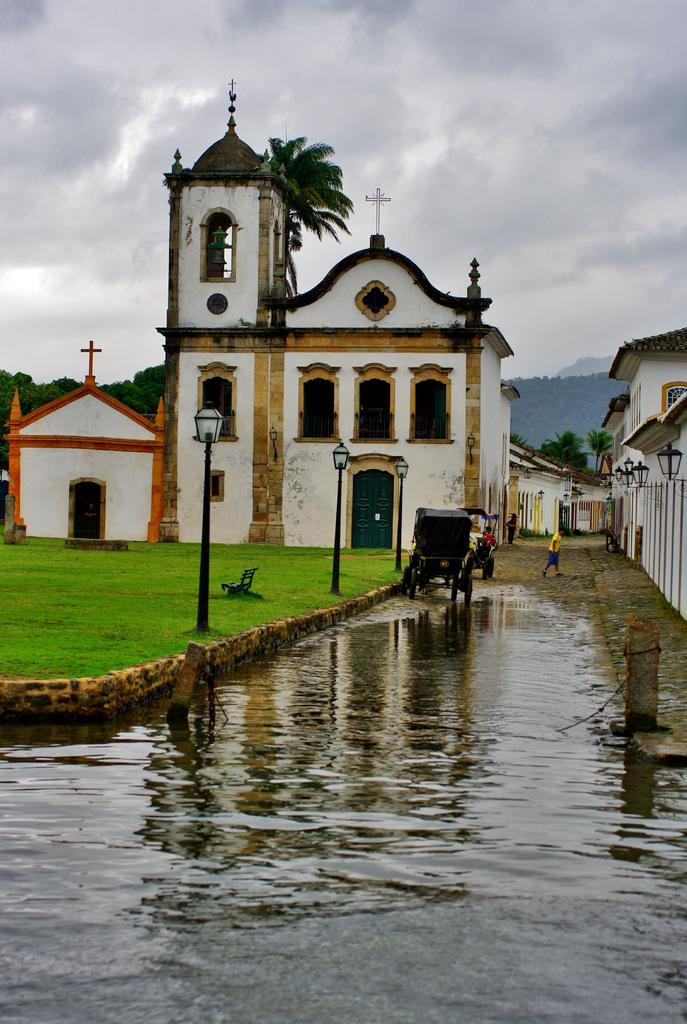What is the primary element in the image? There is water in the image. What can be seen in the background of the image? There are people walking in the background. What structures are visible in the image? Light poles and buildings in white and brown colors are visible in the image. What type of vegetation is present in the image? Trees with green leaves are present. What is the color of the sky in the image? The sky is white in color. Where is the desk located in the image? There is no desk present in the image. What type of sack is being used to carry the water in the image? There is no sack or water-carrying activity depicted in the image. 